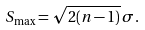<formula> <loc_0><loc_0><loc_500><loc_500>S _ { \max } = \sqrt { 2 ( n - 1 ) } \, \sigma .</formula> 